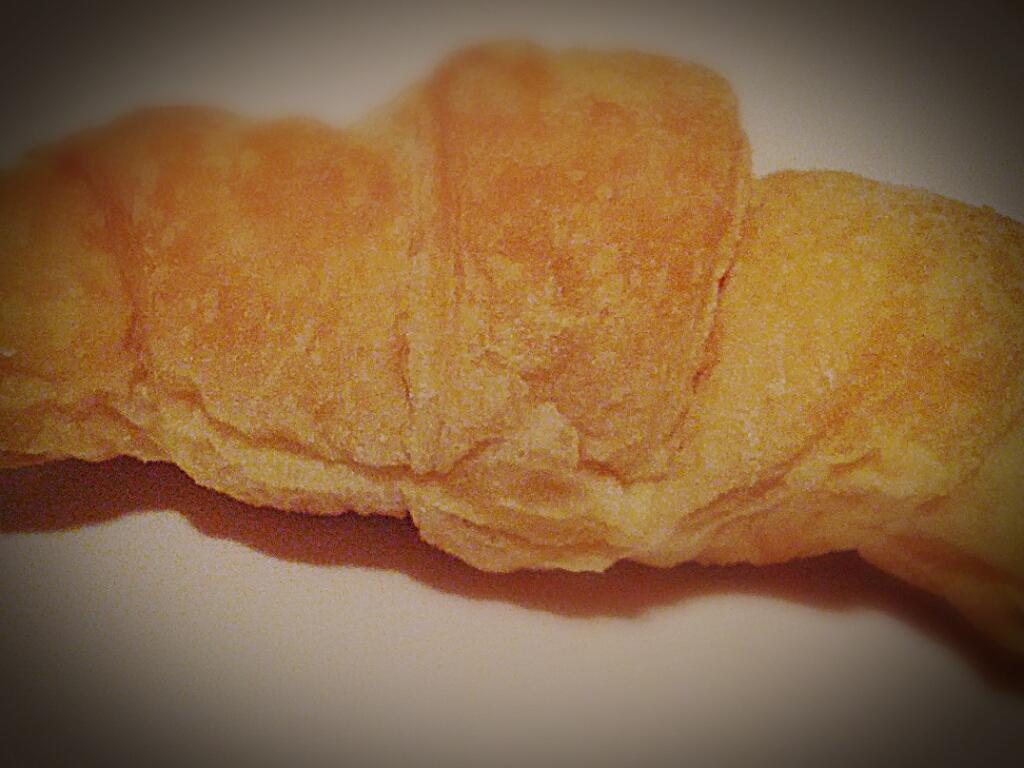What is present in the image? There is food in the image. Where is the food located? The food is on a platform. What type of creature is wearing a sweater in the image? There is no creature or sweater present in the image. Can you describe the ghost in the image? There is no ghost present in the image. 